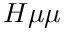Convert formula to latex. <formula><loc_0><loc_0><loc_500><loc_500>H \mu \mu</formula> 